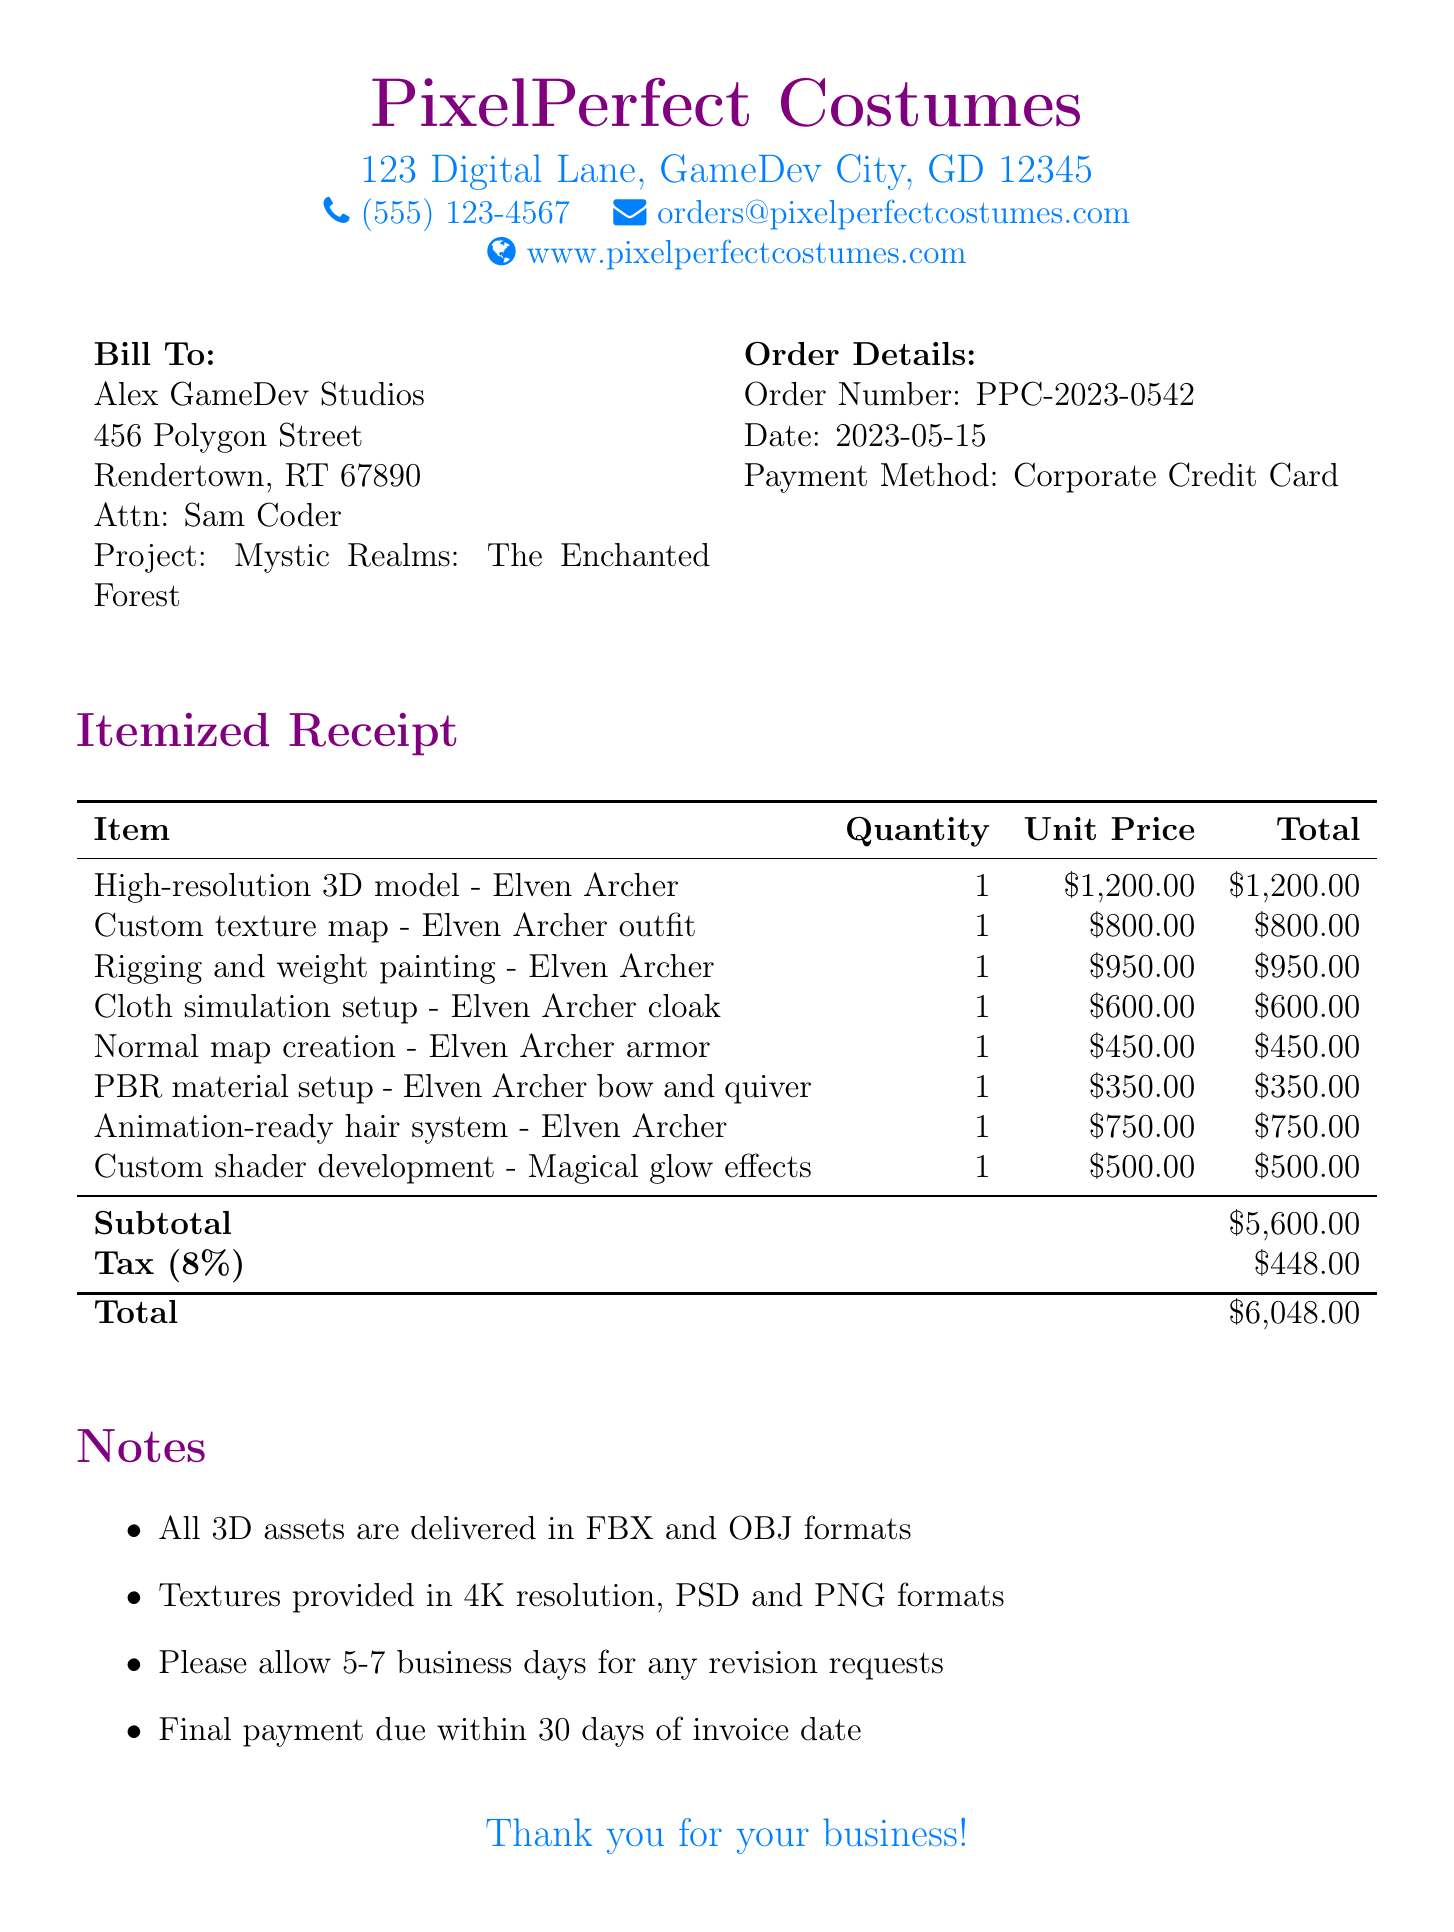What is the company name? The company name is listed at the top of the receipt.
Answer: PixelPerfect Costumes What is the order number? The order number is specified in the order details section.
Answer: PPC-2023-0542 What is the total amount due? The total amount is indicated at the bottom of the receipt, following the tax calculations.
Answer: $6,048.00 What is the date of the order? The date is provided in the order details section of the document.
Answer: 2023-05-15 How many line items are listed in the receipt? The number of line items is directly countable from the itemized section of the document.
Answer: 8 What is the tax rate applied? The tax rate is specifically mentioned in the subtotal section of the receipt.
Answer: 8% What type of payment method was used? The payment method is clearly stated in the order details.
Answer: Corporate Credit Card What is the quantity of the "High-resolution 3D model - Elven Archer"? The quantity is indicated next to the item in the itemized receipt.
Answer: 1 